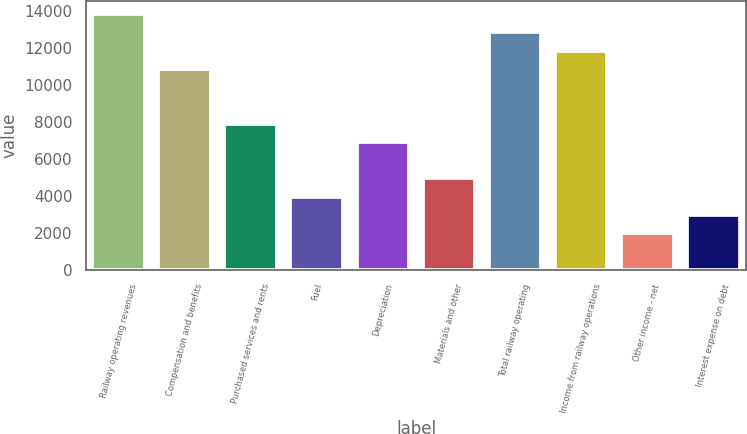Convert chart to OTSL. <chart><loc_0><loc_0><loc_500><loc_500><bar_chart><fcel>Railway operating revenues<fcel>Compensation and benefits<fcel>Purchased services and rents<fcel>Fuel<fcel>Depreciation<fcel>Materials and other<fcel>Total railway operating<fcel>Income from railway operations<fcel>Other income - net<fcel>Interest expense on debt<nl><fcel>13841<fcel>10876.3<fcel>7911.54<fcel>3958.58<fcel>6923.3<fcel>4946.82<fcel>12852.7<fcel>11864.5<fcel>1982.1<fcel>2970.34<nl></chart> 